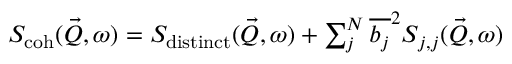Convert formula to latex. <formula><loc_0><loc_0><loc_500><loc_500>\begin{array} { r } { S _ { c o h } ( \vec { Q } , \omega ) = S _ { d i s t i n c t } ( \vec { Q } , \omega ) + \sum _ { j } ^ { N } { \overline { { b _ { j } } } ^ { 2 } } S _ { j , j } ( \vec { Q } , \omega ) } \end{array}</formula> 